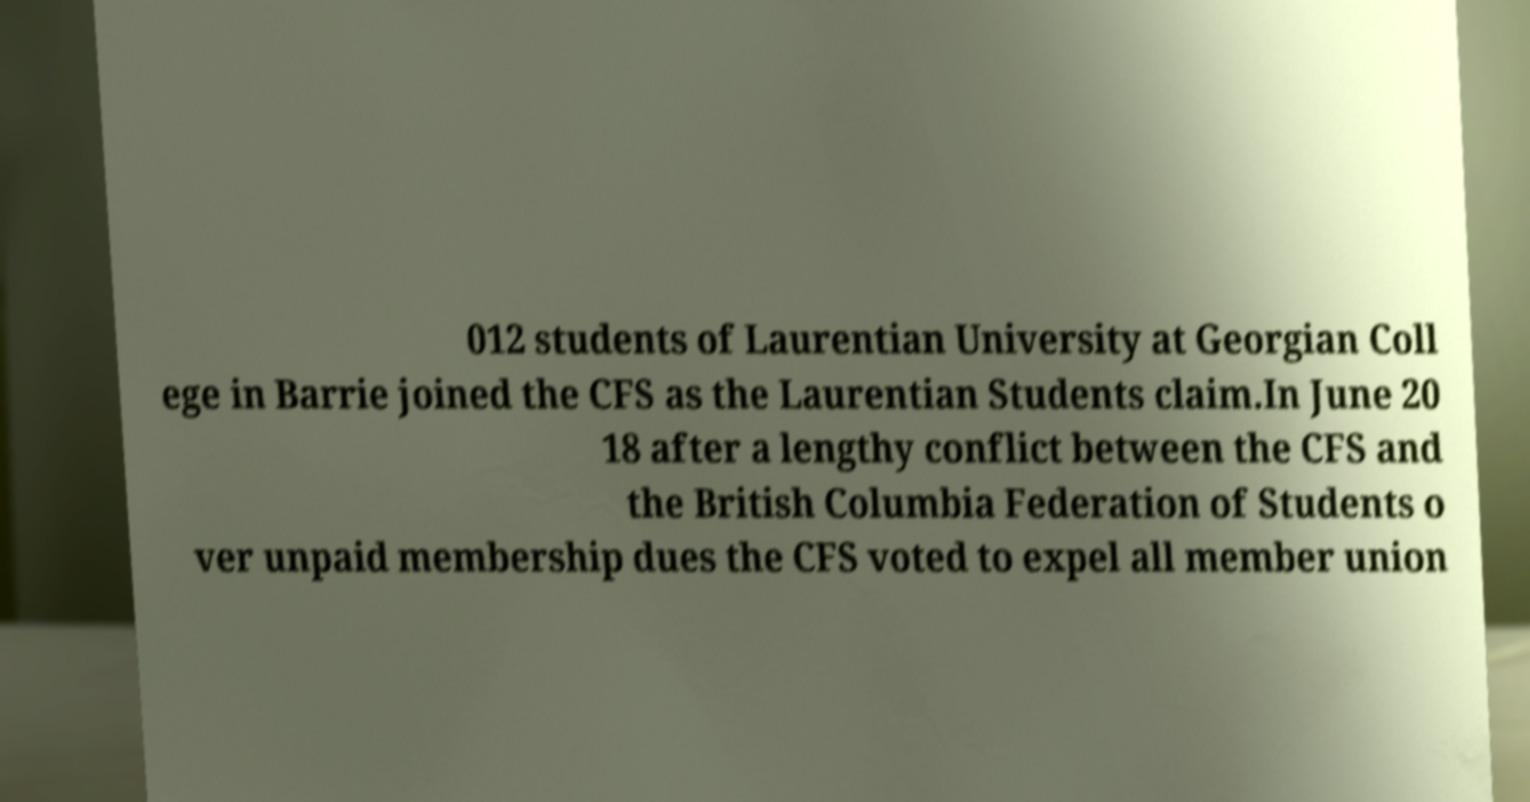Can you read and provide the text displayed in the image?This photo seems to have some interesting text. Can you extract and type it out for me? 012 students of Laurentian University at Georgian Coll ege in Barrie joined the CFS as the Laurentian Students claim.In June 20 18 after a lengthy conflict between the CFS and the British Columbia Federation of Students o ver unpaid membership dues the CFS voted to expel all member union 